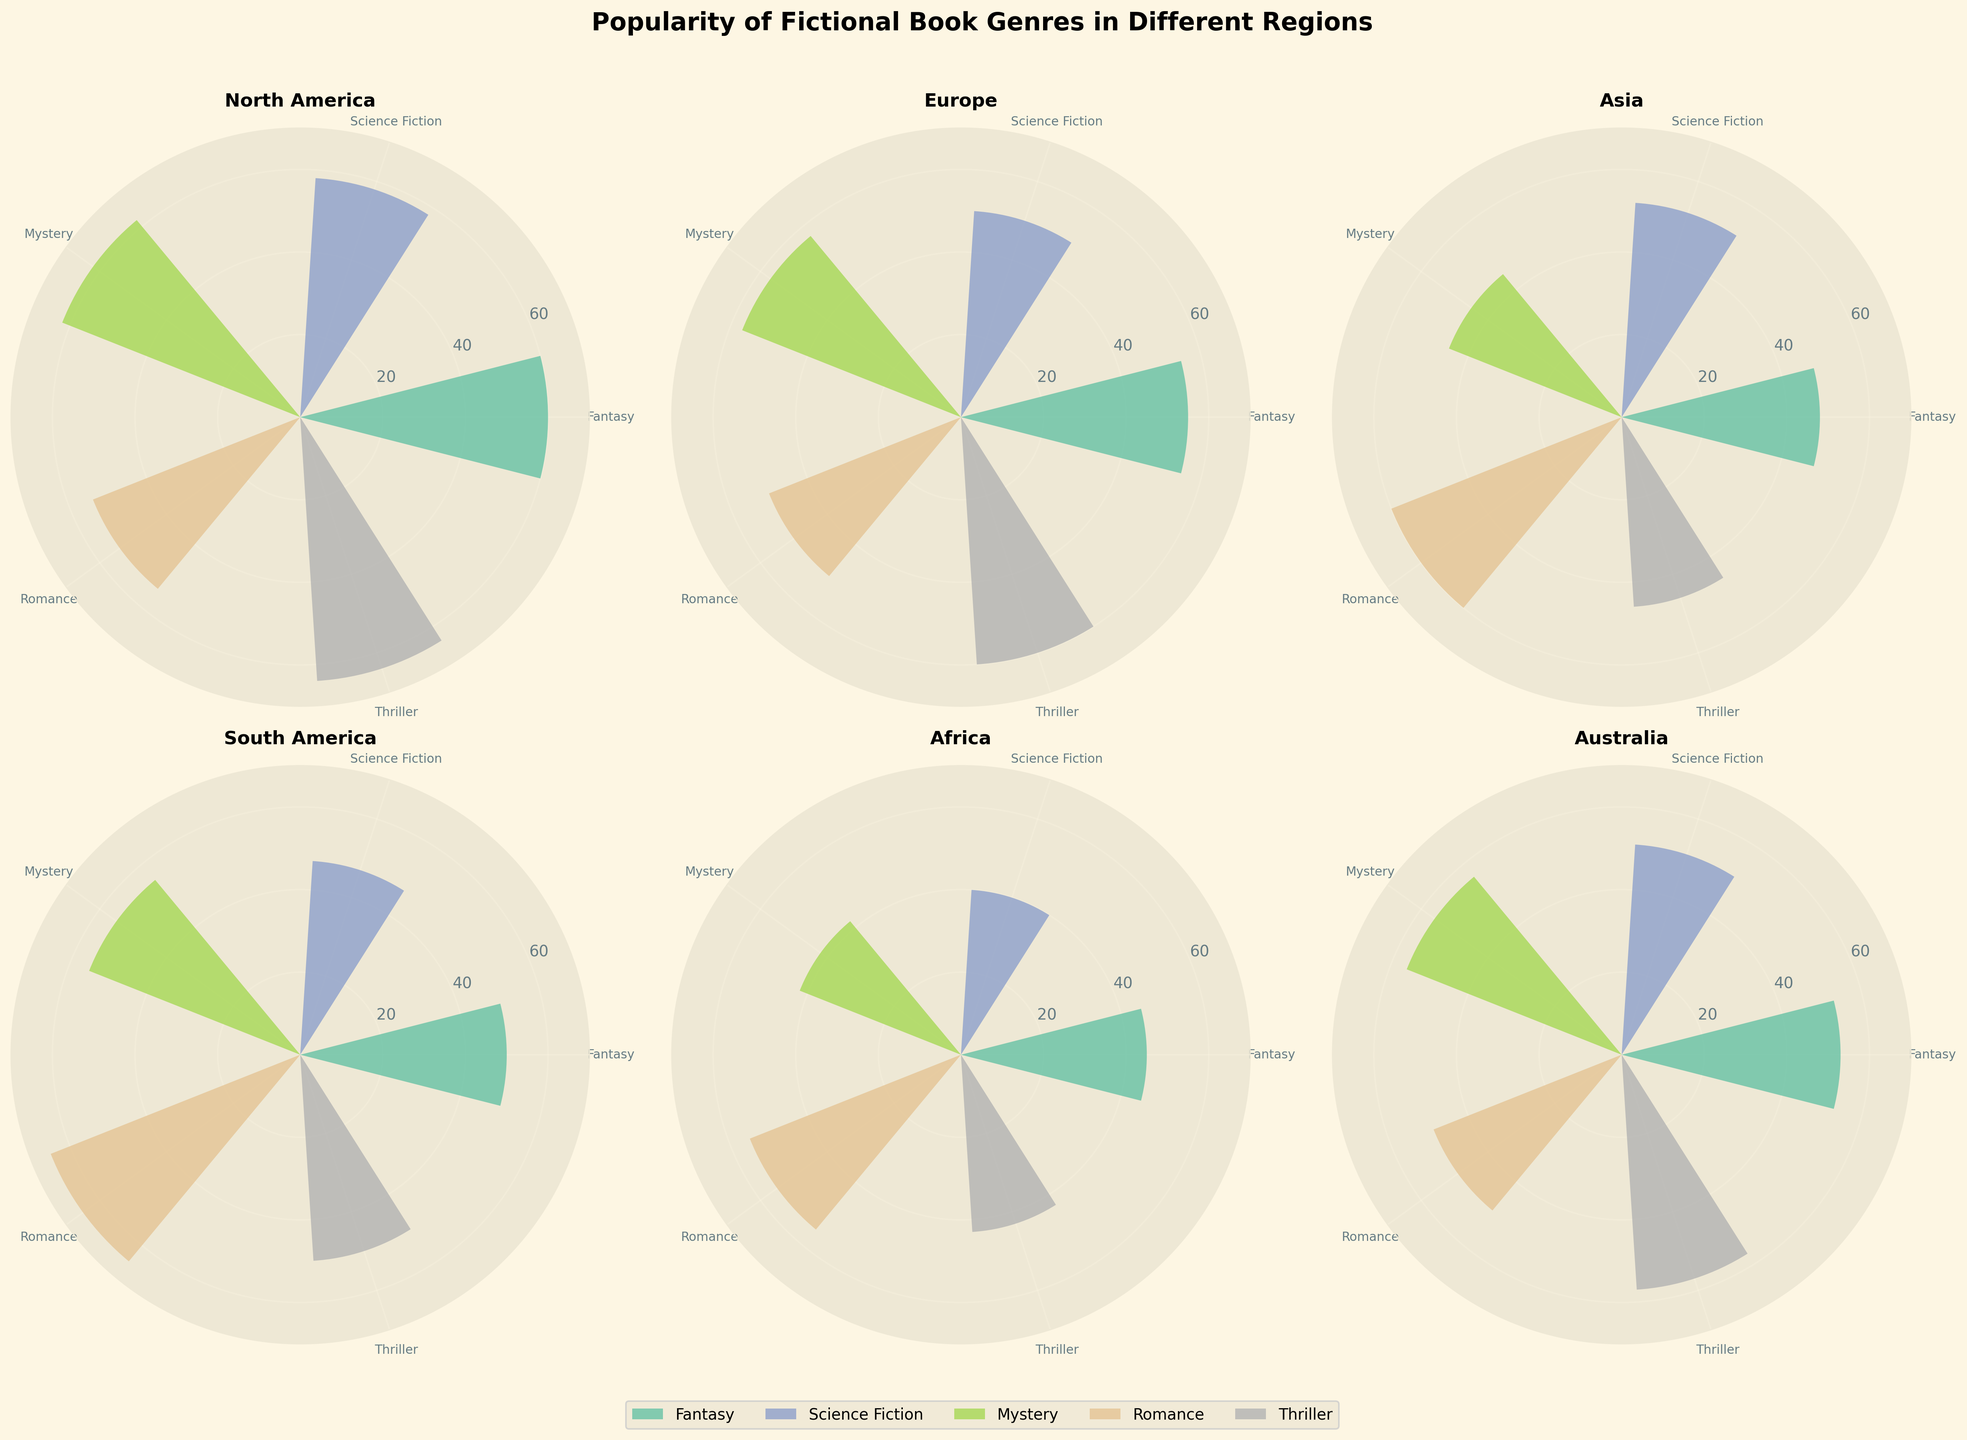What is the most popular genre in North America? The "North America" subplot shows Fantasy, Science Fiction, Mystery, Romance, and Thriller. By comparing the bar lengths, Mystery is the longest.
Answer: Mystery Which region has the highest popularity for Romance? Each subplot represents a different region. The length of bars for Romance is compared across all regions. South America's Romance bar is the longest.
Answer: South America What is the average popularity of Fantasy across all regions? Calculate the average by summing up the popularity numbers for Fantasy (60 + 55 + 48 + 50 + 45 + 53) and dividing by the number of regions (6). The result is 311/6 ≈ 51.83.
Answer: 51.83 Which genre is least popular in Africa? The subplot for Africa shows Fantasy, Science Fiction, Mystery, Romance, and Thriller. Science Fiction has the smallest bar.
Answer: Science Fiction What is the difference in popularity of Thrillers between North America and Asia? Subtract the Thriller popularity in Asia from that in North America: 64 - 46.
Answer: 18 In which region is the popularity of Mystery closest to Science Fiction? Compare the bars for Mystery and Science Fiction in each subplot. In Europe, Mystery (57) and Science Fiction (50) are closest, with a difference of 7.
Answer: Europe Which genre has the smallest range of popularity across all regions? Calculate the range for each genre by subtracting the minimum value from the maximum value:
- Fantasy: 60 - 45 = 15
- Science Fiction: 58 - 40 = 18
- Mystery: 62 - 42 = 20
- Romance: 65 - 49 = 16
- Thriller: 64 - 43 = 21
Fantasy has the smallest range (15).
Answer: Fantasy What is the title of the figure? The title is located above the subplots in large, bold text. It reads "Popularity of Fictional Book Genres in Different Regions."
Answer: Popularity of Fictional Book Genres in Different Regions Which genres are more popular in North America than in Europe? Compare the heights of bars for each genre in North America's subplot to those in Europe's subplot. 
- Fantasy in NA (60) > Europe (55)
- Science Fiction in NA (58) > Europe (50)
- Mystery in NA (62) > Europe (57)
- Romance in NA (54) < Europe (50)
- Thriller in NA (64) > Europe (60)
So, Fantasy, Science Fiction, Mystery, and Thriller are more popular in North America than in Europe.
Answer: Fantasy, Science Fiction, Mystery, Thriller 